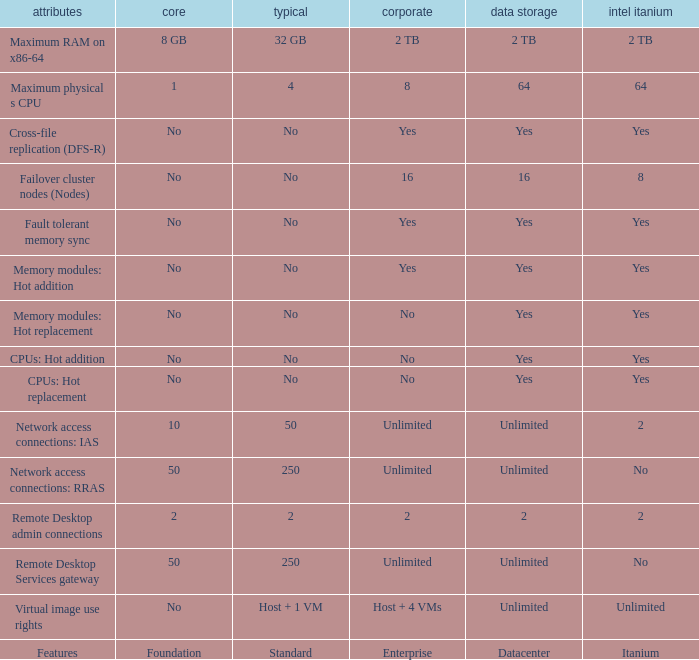What is the Enterprise for teh memory modules: hot replacement Feature that has a Datacenter of Yes? No. 